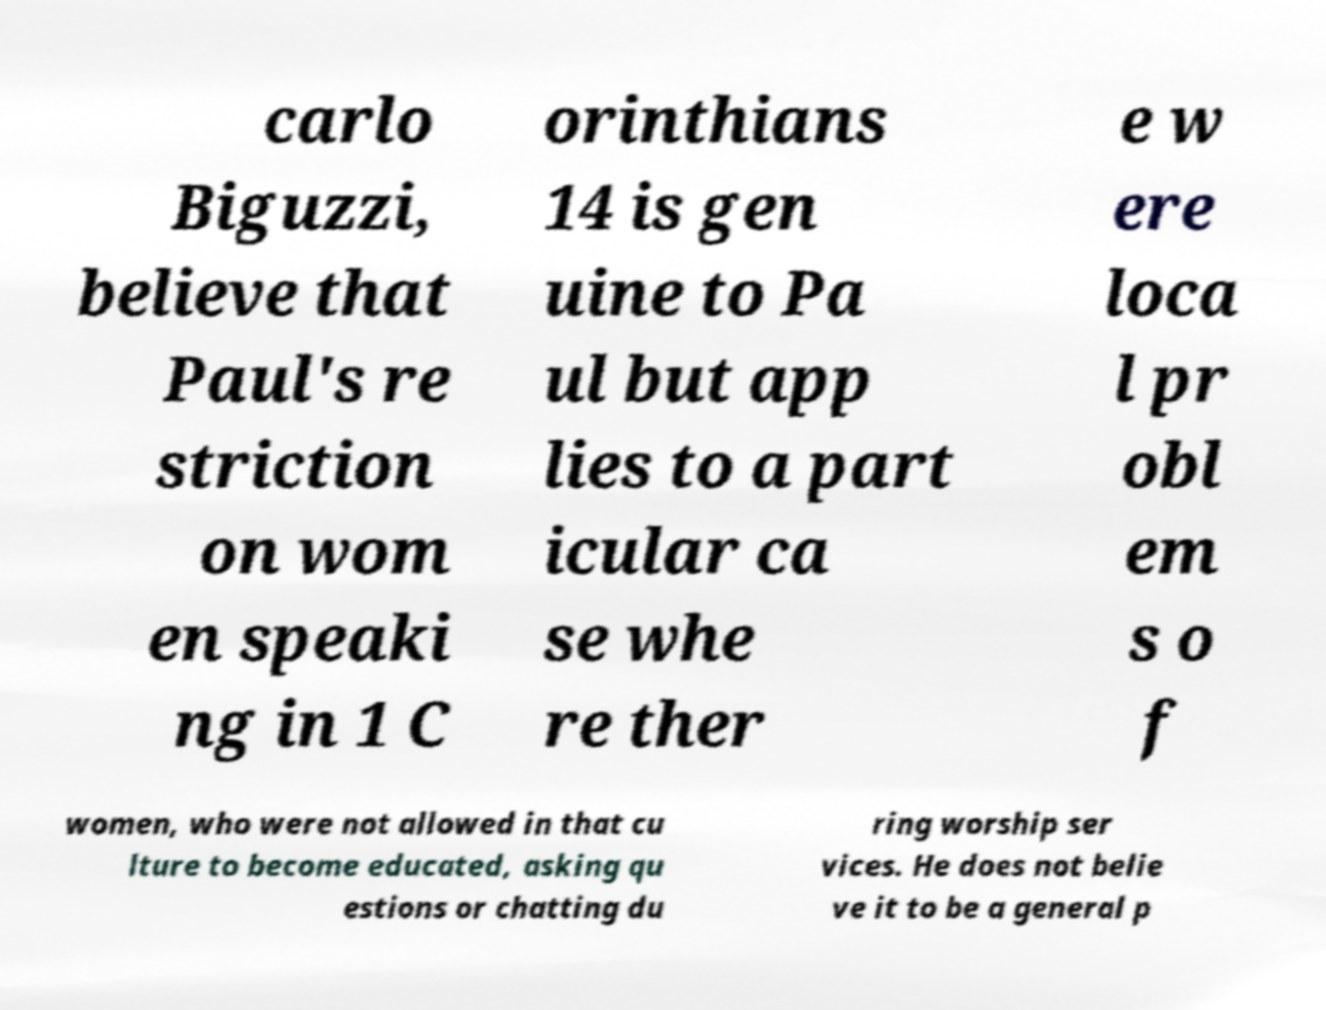Could you extract and type out the text from this image? carlo Biguzzi, believe that Paul's re striction on wom en speaki ng in 1 C orinthians 14 is gen uine to Pa ul but app lies to a part icular ca se whe re ther e w ere loca l pr obl em s o f women, who were not allowed in that cu lture to become educated, asking qu estions or chatting du ring worship ser vices. He does not belie ve it to be a general p 